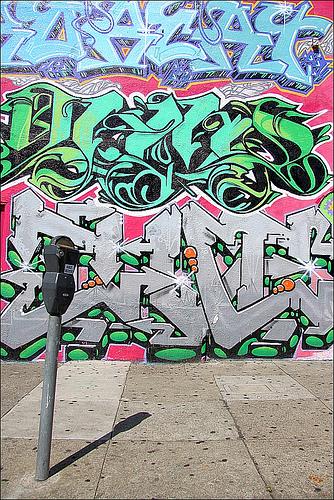What is the name of the metal item in the front-left of the picture?
Be succinct. Parking meter. Is the sun high or low on the horizon?
Write a very short answer. High. What is this called on the wall??
Keep it brief. Graffiti. 